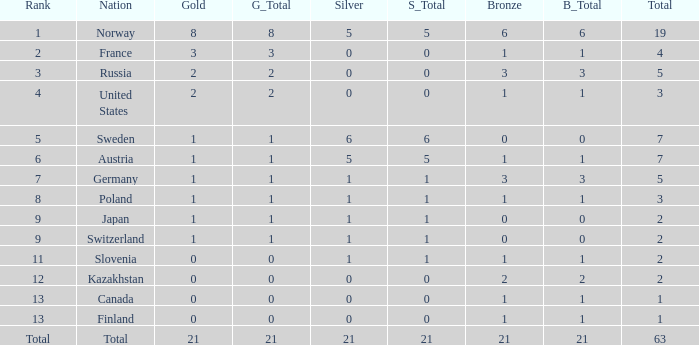What rank contains a gold under 1, and a silver more than 0? 11.0. 